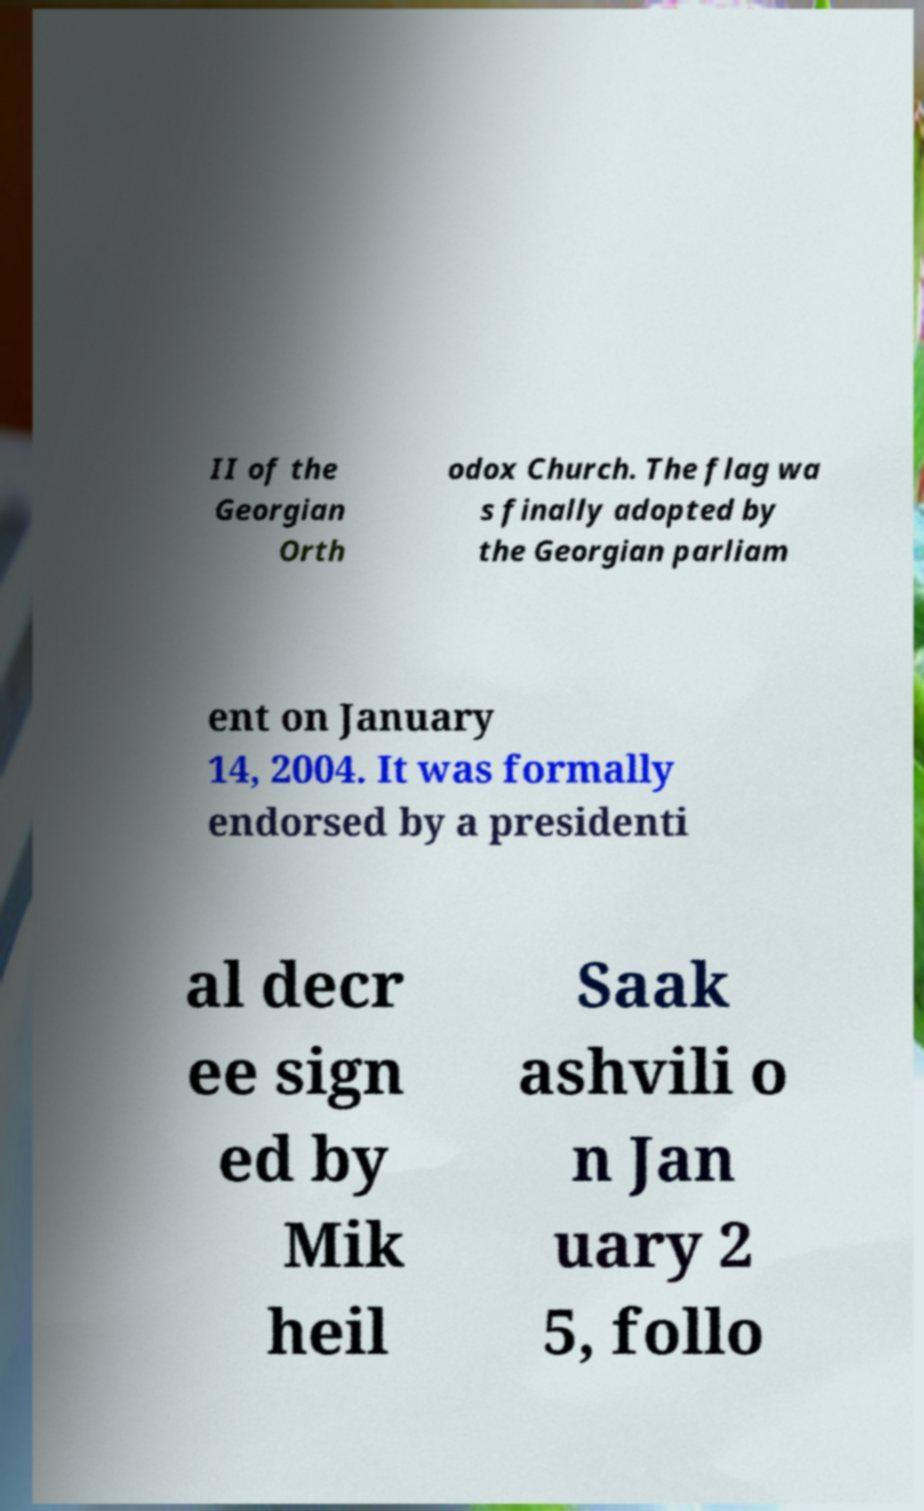Please read and relay the text visible in this image. What does it say? II of the Georgian Orth odox Church. The flag wa s finally adopted by the Georgian parliam ent on January 14, 2004. It was formally endorsed by a presidenti al decr ee sign ed by Mik heil Saak ashvili o n Jan uary 2 5, follo 